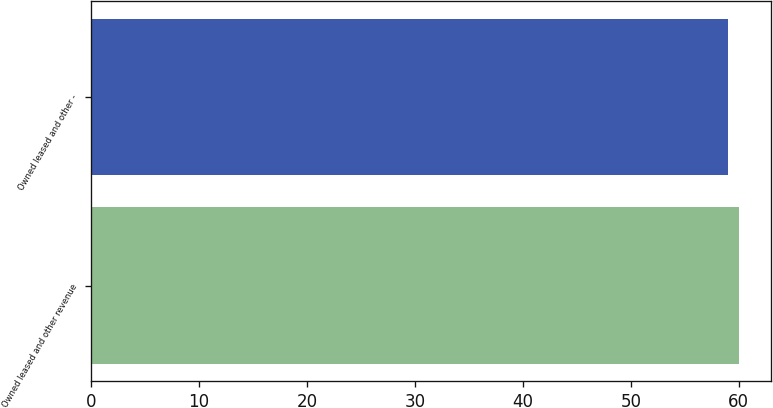Convert chart. <chart><loc_0><loc_0><loc_500><loc_500><bar_chart><fcel>Owned leased and other revenue<fcel>Owned leased and other -<nl><fcel>60<fcel>59<nl></chart> 